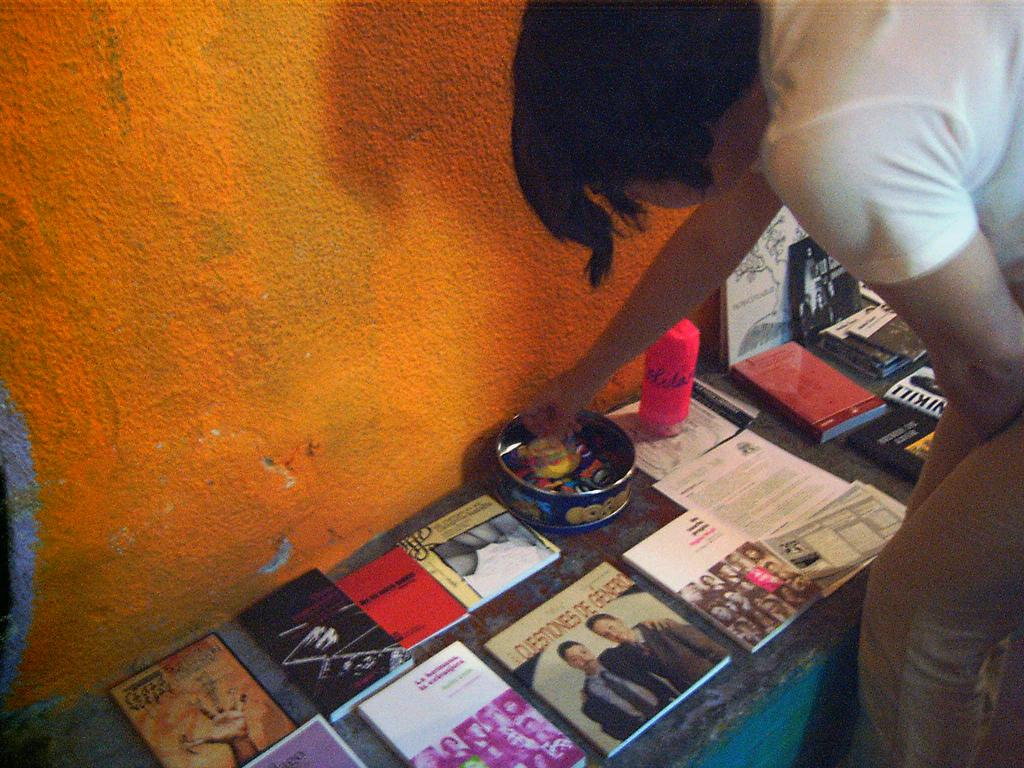Who or what is on the right side of the image? There is a person on the right side of the image. What is located near the person? There is a stand near the person. What is on the stand? There are many books on the stand. What else can be seen in the image? There is a box with some items in the image, and there is a wall near the stand. How many legs does the wire have in the image? There is no wire present in the image, so it is not possible to determine the number of legs it might have. 